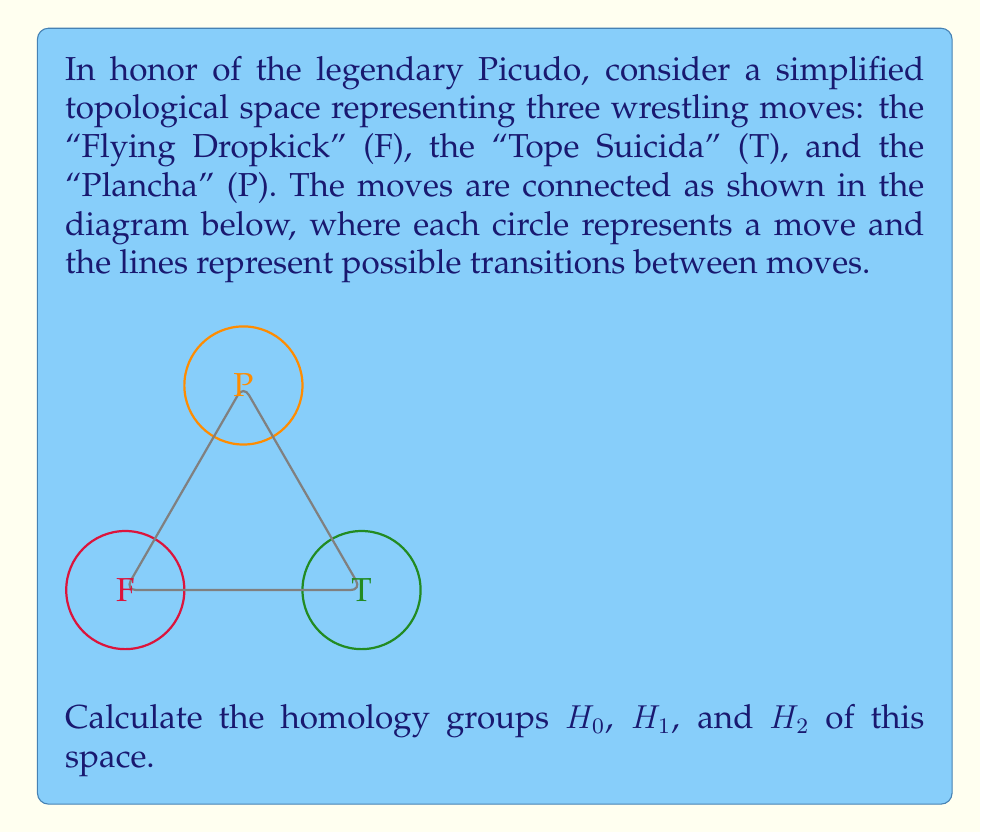Give your solution to this math problem. To find the homology groups of this space, we'll follow these steps:

1) First, let's identify the simplicial complex structure:
   - 0-simplices: F, T, P (3 vertices)
   - 1-simplices: FT, TP, PF (3 edges)
   - 2-simplices: none (the triangle is not filled)

2) Now, let's calculate the chain groups:
   $C_0 = \mathbb{Z} \oplus \mathbb{Z} \oplus \mathbb{Z}$ (generated by F, T, P)
   $C_1 = \mathbb{Z} \oplus \mathbb{Z} \oplus \mathbb{Z}$ (generated by FT, TP, PF)
   $C_2 = 0$ (no 2-simplices)

3) Next, we'll determine the boundary maps:
   $\partial_1: C_1 \to C_0$
   $\partial_1(FT) = T - F$
   $\partial_1(TP) = P - T$
   $\partial_1(PF) = F - P$

   $\partial_2: C_2 \to C_1$ is trivial since $C_2 = 0$

4) Now, let's calculate the kernel and image of these maps:
   $ker(\partial_1) = \{a(FT) + b(TP) + c(PF) | a+b+c = 0\} \cong \mathbb{Z} \oplus \mathbb{Z}$
   $im(\partial_1) = \{x(F) + y(T) + z(P) | x+y+z = 0\} \cong \mathbb{Z} \oplus \mathbb{Z}$
   $ker(\partial_0) = C_0 \cong \mathbb{Z} \oplus \mathbb{Z} \oplus \mathbb{Z}$
   $im(\partial_2) = 0$

5) Finally, we can calculate the homology groups:
   $H_0 = ker(\partial_0) / im(\partial_1) \cong \mathbb{Z}$
   $H_1 = ker(\partial_1) / im(\partial_2) \cong \mathbb{Z} \oplus \mathbb{Z}$
   $H_2 = ker(\partial_2) / im(\partial_3) = 0$
Answer: $H_0 \cong \mathbb{Z}$, $H_1 \cong \mathbb{Z} \oplus \mathbb{Z}$, $H_2 \cong 0$ 